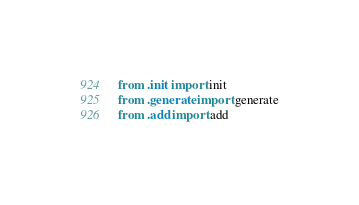Convert code to text. <code><loc_0><loc_0><loc_500><loc_500><_Python_>from .init import init
from .generate import generate
from .add import add
</code> 